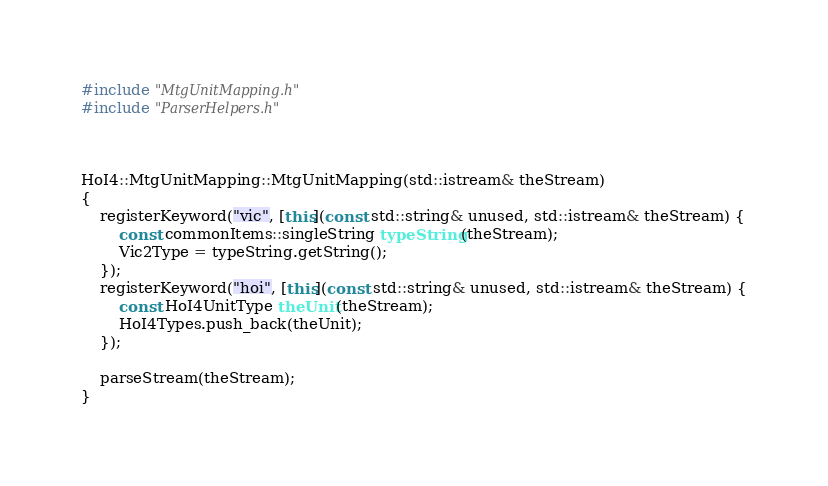Convert code to text. <code><loc_0><loc_0><loc_500><loc_500><_C++_>#include "MtgUnitMapping.h"
#include "ParserHelpers.h"



HoI4::MtgUnitMapping::MtgUnitMapping(std::istream& theStream)
{
	registerKeyword("vic", [this](const std::string& unused, std::istream& theStream) {
		const commonItems::singleString typeString(theStream);
		Vic2Type = typeString.getString();
	});
	registerKeyword("hoi", [this](const std::string& unused, std::istream& theStream) {
		const HoI4UnitType theUnit(theStream);
		HoI4Types.push_back(theUnit);
	});

	parseStream(theStream);
}</code> 